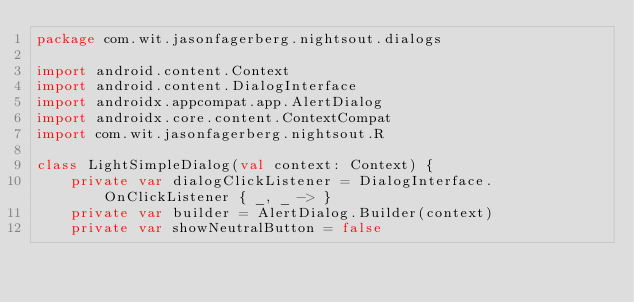<code> <loc_0><loc_0><loc_500><loc_500><_Kotlin_>package com.wit.jasonfagerberg.nightsout.dialogs

import android.content.Context
import android.content.DialogInterface
import androidx.appcompat.app.AlertDialog
import androidx.core.content.ContextCompat
import com.wit.jasonfagerberg.nightsout.R

class LightSimpleDialog(val context: Context) {
    private var dialogClickListener = DialogInterface.OnClickListener { _, _ -> }
    private var builder = AlertDialog.Builder(context)
    private var showNeutralButton = false
</code> 